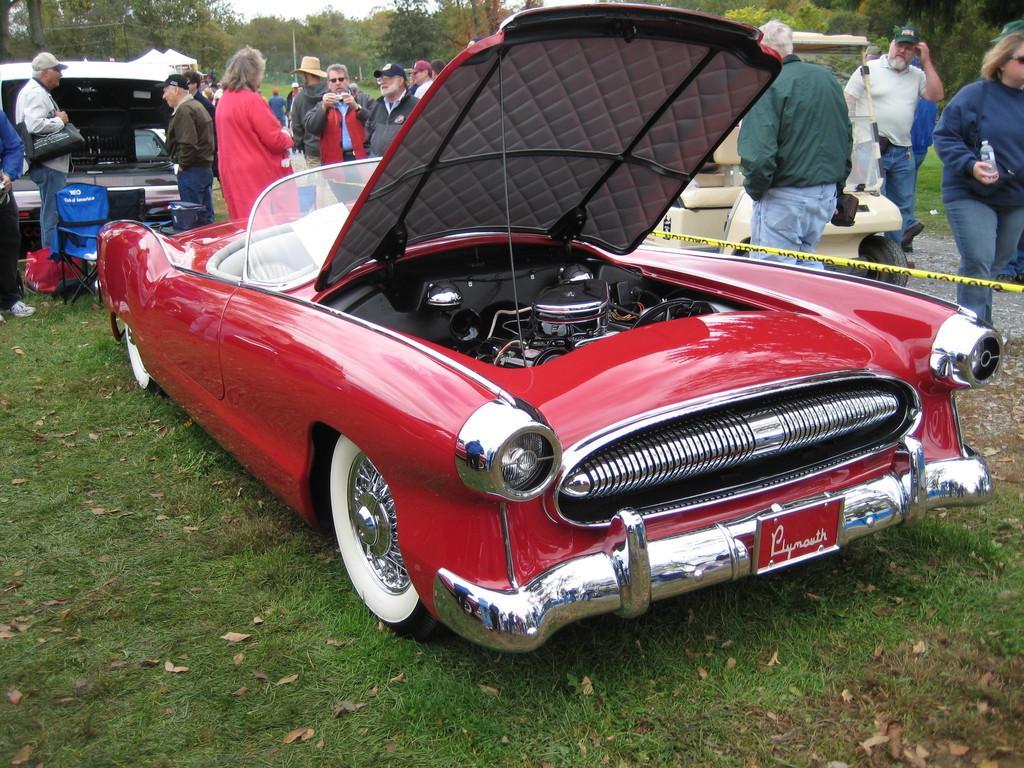Please provide a concise description of this image. In this picture we can see vehicles on the grass with open bonnets and a yellow sticker. In the background, we can see people standing and looking somewhere. The place is surrounded by trees and plants. 